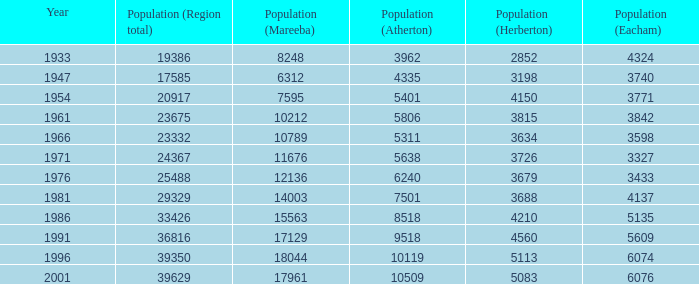How many figures are given for the region's total in 1947? 1.0. 